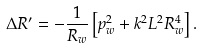Convert formula to latex. <formula><loc_0><loc_0><loc_500><loc_500>\Delta R ^ { \prime } = - \frac { 1 } { R _ { w } } \left [ p _ { w } ^ { 2 } + k ^ { 2 } L ^ { 2 } R _ { w } ^ { 4 } \right ] .</formula> 